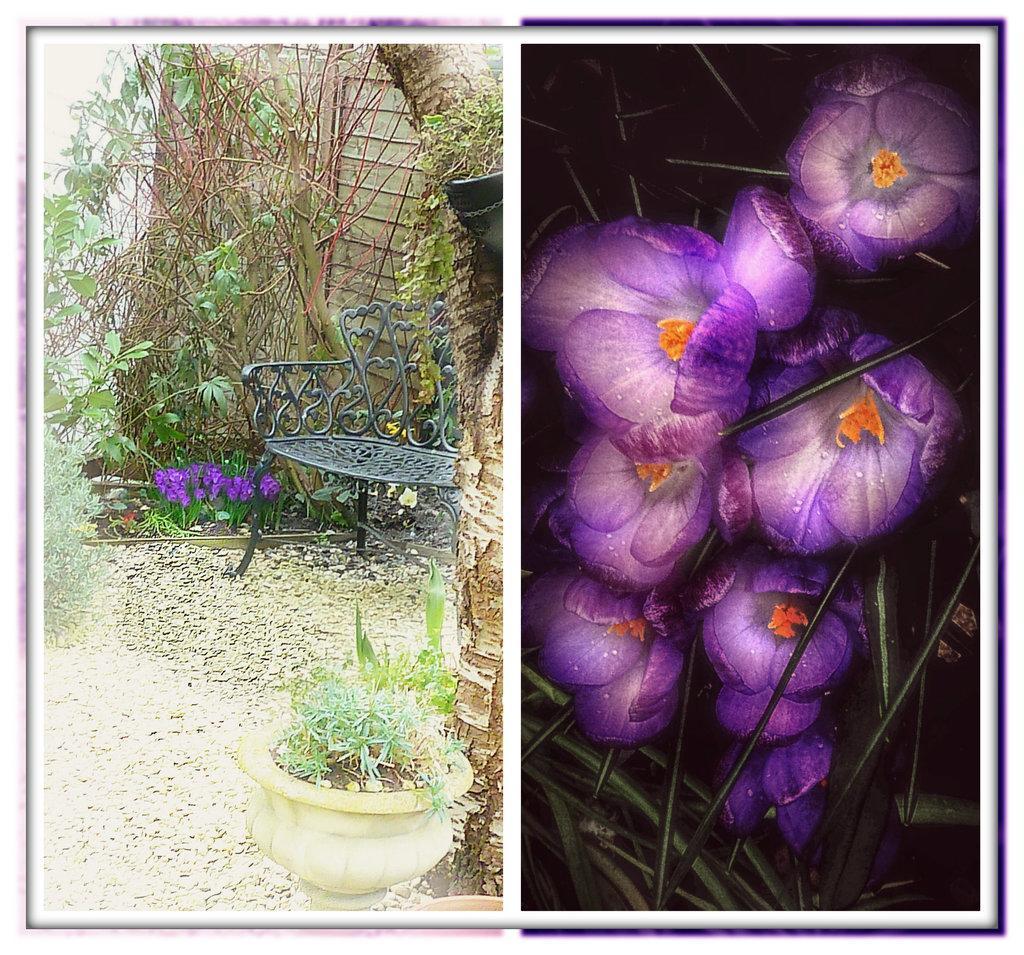Please provide a concise description of this image. This is a collage image. On the left side of the collage image we can see creepers, plants, house plant, tree and a bench on the ground. On the right side of the collage image we can see the animated image of flowers. 